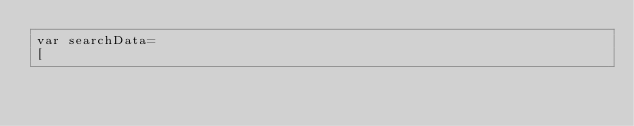Convert code to text. <code><loc_0><loc_0><loc_500><loc_500><_JavaScript_>var searchData=
[</code> 